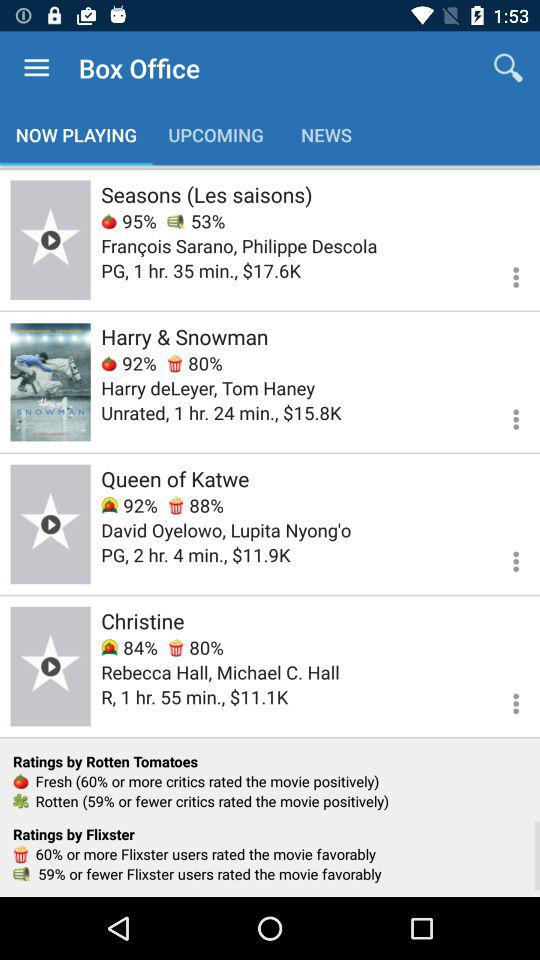Which movie has a higher average rating, Seasons or Christine?
Answer the question using a single word or phrase. Christine 